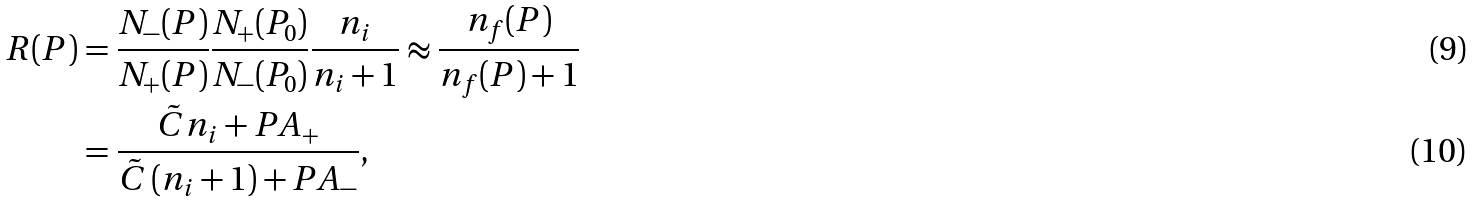Convert formula to latex. <formula><loc_0><loc_0><loc_500><loc_500>R ( P ) & = \frac { N _ { - } ( P ) } { N _ { + } ( P ) } \frac { N _ { + } ( P _ { 0 } ) } { N _ { - } ( P _ { 0 } ) } \frac { n _ { i } } { n _ { i } + 1 } \approx \frac { n _ { f } ( P ) } { n _ { f } ( P ) + 1 } \\ & = \frac { \tilde { C } n _ { i } + P A _ { + } } { \tilde { C } \left ( n _ { i } + 1 \right ) + P A _ { - } } ,</formula> 